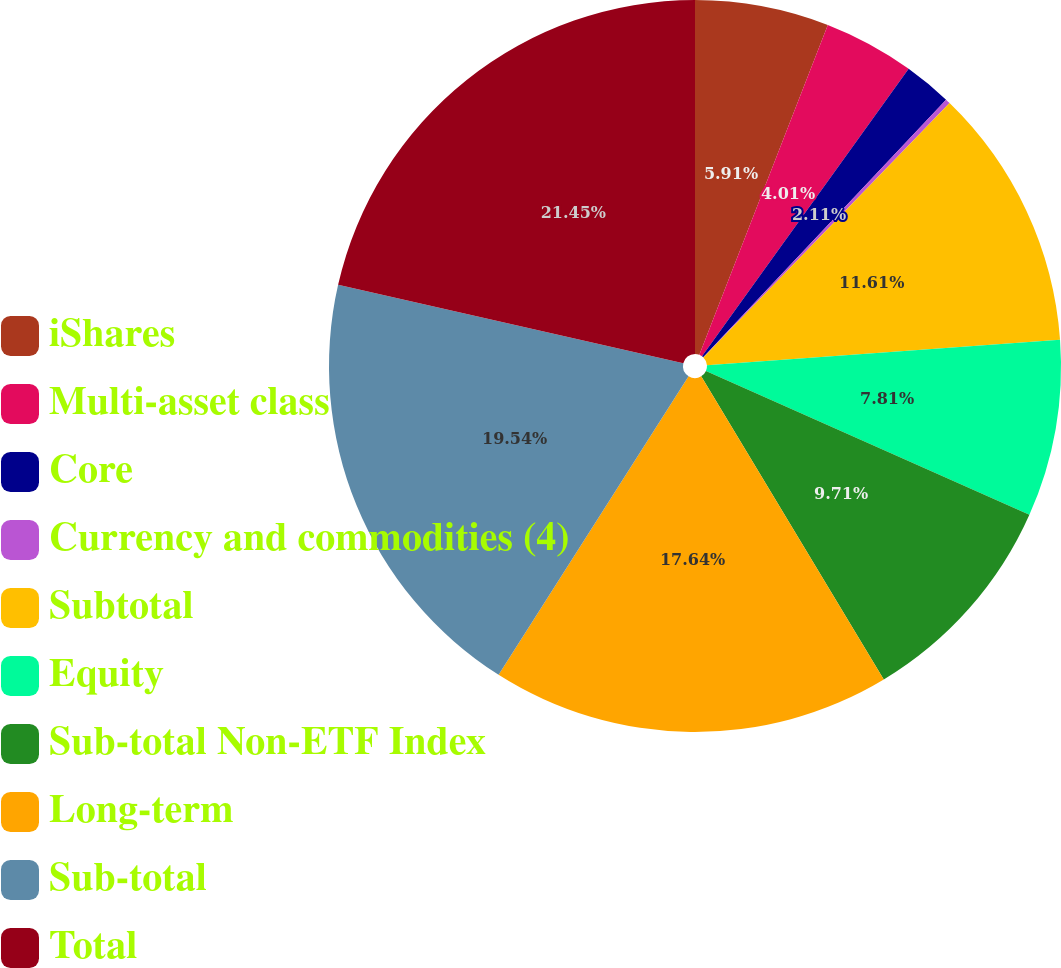<chart> <loc_0><loc_0><loc_500><loc_500><pie_chart><fcel>iShares<fcel>Multi-asset class<fcel>Core<fcel>Currency and commodities (4)<fcel>Subtotal<fcel>Equity<fcel>Sub-total Non-ETF Index<fcel>Long-term<fcel>Sub-total<fcel>Total<nl><fcel>5.91%<fcel>4.01%<fcel>2.11%<fcel>0.21%<fcel>11.61%<fcel>7.81%<fcel>9.71%<fcel>17.64%<fcel>19.54%<fcel>21.44%<nl></chart> 